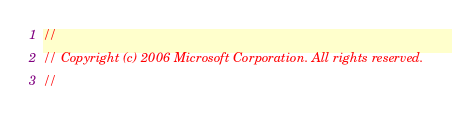<code> <loc_0><loc_0><loc_500><loc_500><_C#_>//
// Copyright (c) 2006 Microsoft Corporation. All rights reserved.
// </code> 